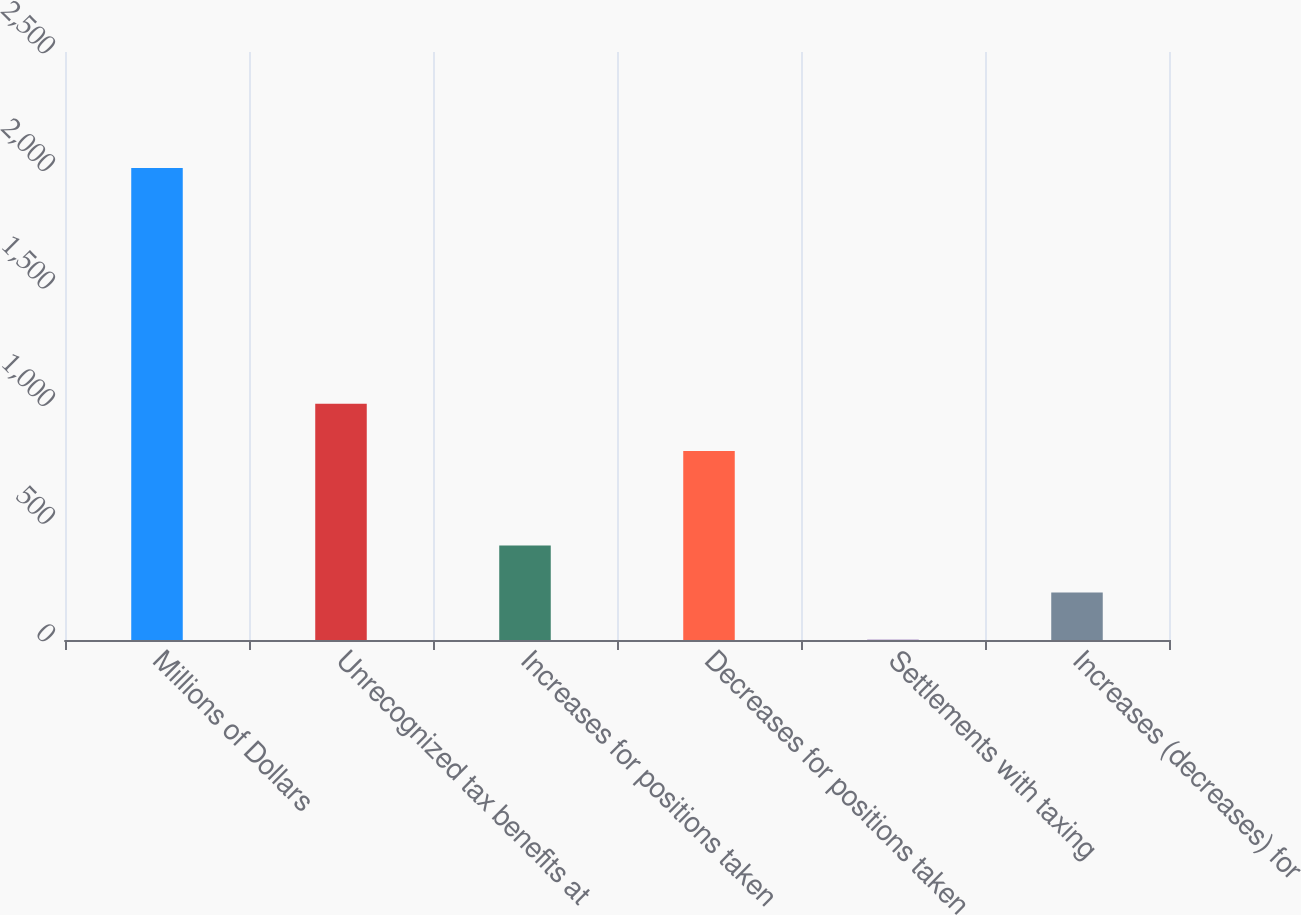<chart> <loc_0><loc_0><loc_500><loc_500><bar_chart><fcel>Millions of Dollars<fcel>Unrecognized tax benefits at<fcel>Increases for positions taken<fcel>Decreases for positions taken<fcel>Settlements with taxing<fcel>Increases (decreases) for<nl><fcel>2007<fcel>1004<fcel>402.2<fcel>803.4<fcel>1<fcel>201.6<nl></chart> 